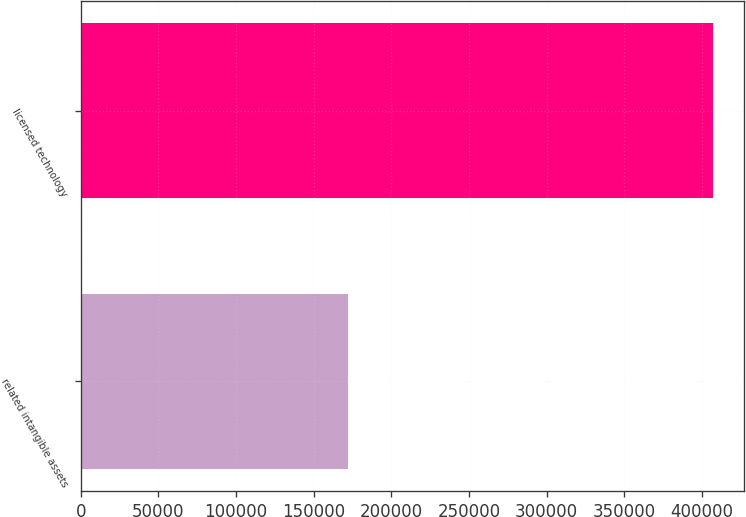Convert chart to OTSL. <chart><loc_0><loc_0><loc_500><loc_500><bar_chart><fcel>related intangible assets<fcel>licensed technology<nl><fcel>172039<fcel>407002<nl></chart> 